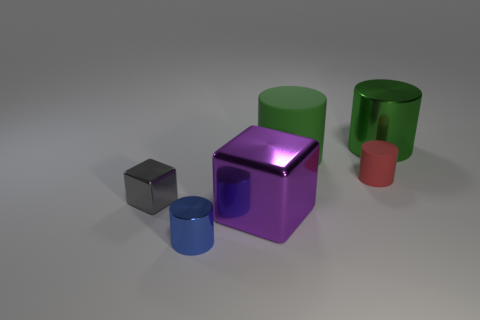Subtract all brown cubes. How many green cylinders are left? 2 Subtract all small metal cylinders. How many cylinders are left? 3 Subtract all blue cylinders. How many cylinders are left? 3 Add 4 blue objects. How many objects exist? 10 Subtract 1 cylinders. How many cylinders are left? 3 Subtract all cylinders. How many objects are left? 2 Add 5 large cyan cylinders. How many large cyan cylinders exist? 5 Subtract 0 yellow cylinders. How many objects are left? 6 Subtract all purple cylinders. Subtract all yellow blocks. How many cylinders are left? 4 Subtract all purple metal things. Subtract all tiny yellow metal cubes. How many objects are left? 5 